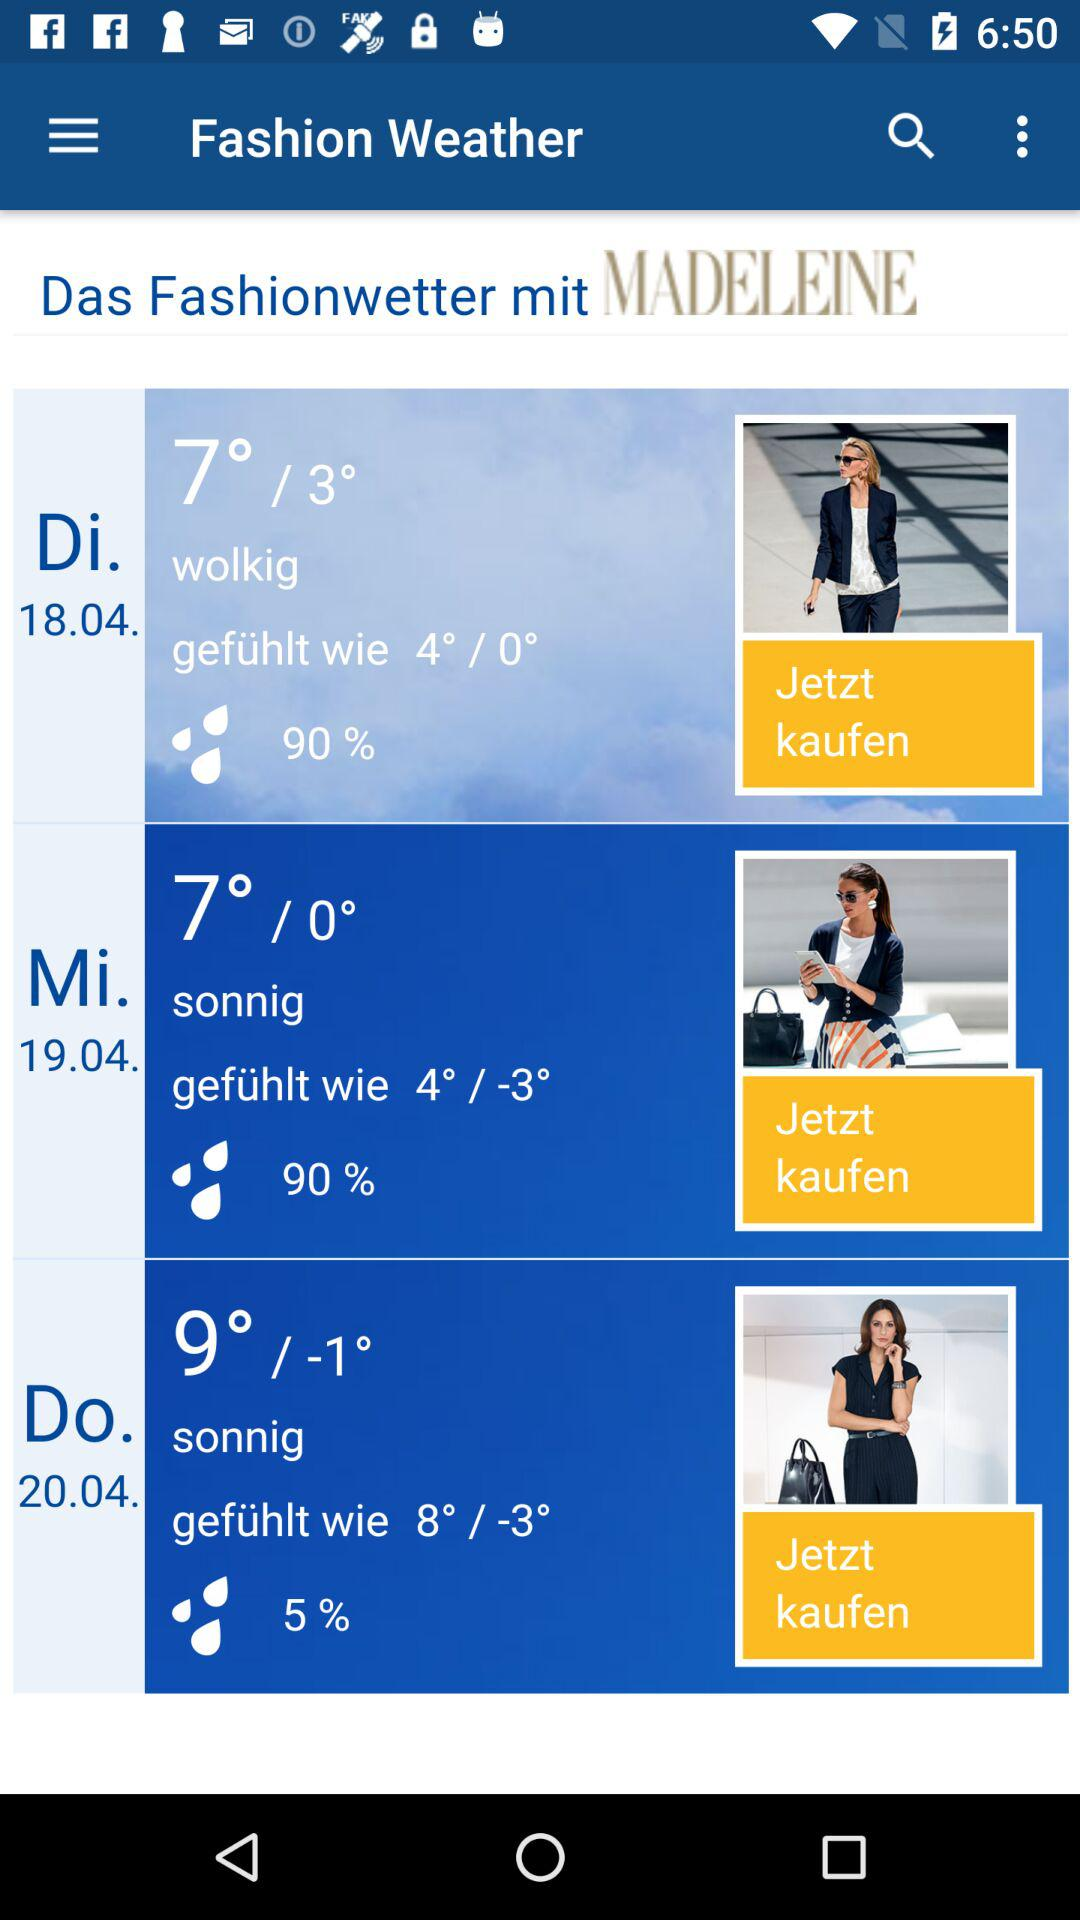How many degrees is the difference between the highest and lowest temperatures in the forecast?
Answer the question using a single word or phrase. 12 